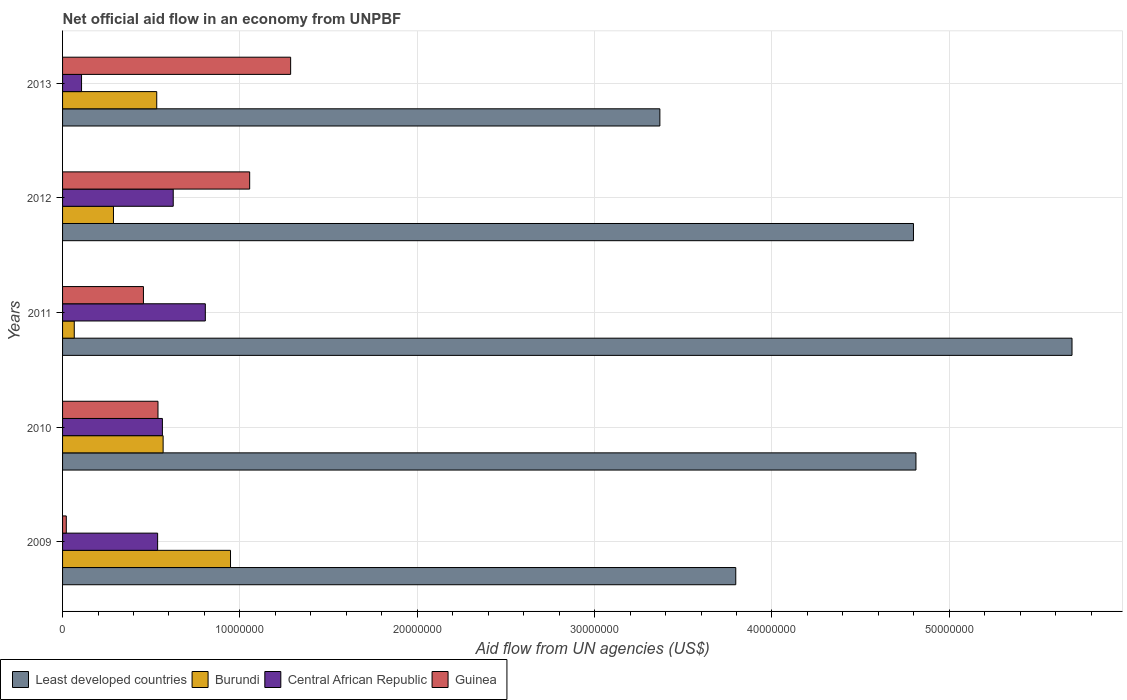How many groups of bars are there?
Keep it short and to the point. 5. Are the number of bars per tick equal to the number of legend labels?
Your response must be concise. Yes. Are the number of bars on each tick of the Y-axis equal?
Your response must be concise. Yes. How many bars are there on the 2nd tick from the top?
Ensure brevity in your answer.  4. How many bars are there on the 5th tick from the bottom?
Ensure brevity in your answer.  4. What is the label of the 4th group of bars from the top?
Give a very brief answer. 2010. In how many cases, is the number of bars for a given year not equal to the number of legend labels?
Ensure brevity in your answer.  0. What is the net official aid flow in Burundi in 2010?
Provide a succinct answer. 5.67e+06. Across all years, what is the maximum net official aid flow in Least developed countries?
Keep it short and to the point. 5.69e+07. Across all years, what is the minimum net official aid flow in Central African Republic?
Provide a succinct answer. 1.07e+06. In which year was the net official aid flow in Guinea minimum?
Offer a terse response. 2009. What is the total net official aid flow in Burundi in the graph?
Your answer should be very brief. 2.40e+07. What is the difference between the net official aid flow in Central African Republic in 2009 and that in 2013?
Provide a succinct answer. 4.29e+06. What is the difference between the net official aid flow in Guinea in 2009 and the net official aid flow in Burundi in 2013?
Provide a succinct answer. -5.10e+06. What is the average net official aid flow in Guinea per year?
Make the answer very short. 6.71e+06. In the year 2013, what is the difference between the net official aid flow in Least developed countries and net official aid flow in Guinea?
Your answer should be compact. 2.08e+07. In how many years, is the net official aid flow in Least developed countries greater than 36000000 US$?
Keep it short and to the point. 4. What is the ratio of the net official aid flow in Guinea in 2009 to that in 2013?
Offer a very short reply. 0.02. What is the difference between the highest and the second highest net official aid flow in Least developed countries?
Provide a short and direct response. 8.80e+06. What is the difference between the highest and the lowest net official aid flow in Burundi?
Offer a very short reply. 8.81e+06. Is the sum of the net official aid flow in Central African Republic in 2010 and 2012 greater than the maximum net official aid flow in Least developed countries across all years?
Your answer should be compact. No. What does the 3rd bar from the top in 2011 represents?
Ensure brevity in your answer.  Burundi. What does the 4th bar from the bottom in 2010 represents?
Keep it short and to the point. Guinea. Is it the case that in every year, the sum of the net official aid flow in Least developed countries and net official aid flow in Burundi is greater than the net official aid flow in Guinea?
Make the answer very short. Yes. How many bars are there?
Your answer should be compact. 20. How many years are there in the graph?
Make the answer very short. 5. What is the difference between two consecutive major ticks on the X-axis?
Provide a succinct answer. 1.00e+07. Are the values on the major ticks of X-axis written in scientific E-notation?
Your response must be concise. No. Does the graph contain grids?
Keep it short and to the point. Yes. Where does the legend appear in the graph?
Ensure brevity in your answer.  Bottom left. What is the title of the graph?
Provide a short and direct response. Net official aid flow in an economy from UNPBF. What is the label or title of the X-axis?
Your answer should be very brief. Aid flow from UN agencies (US$). What is the label or title of the Y-axis?
Your response must be concise. Years. What is the Aid flow from UN agencies (US$) in Least developed countries in 2009?
Ensure brevity in your answer.  3.80e+07. What is the Aid flow from UN agencies (US$) of Burundi in 2009?
Provide a short and direct response. 9.47e+06. What is the Aid flow from UN agencies (US$) of Central African Republic in 2009?
Offer a terse response. 5.36e+06. What is the Aid flow from UN agencies (US$) in Guinea in 2009?
Make the answer very short. 2.10e+05. What is the Aid flow from UN agencies (US$) of Least developed countries in 2010?
Provide a succinct answer. 4.81e+07. What is the Aid flow from UN agencies (US$) in Burundi in 2010?
Give a very brief answer. 5.67e+06. What is the Aid flow from UN agencies (US$) in Central African Republic in 2010?
Your answer should be very brief. 5.63e+06. What is the Aid flow from UN agencies (US$) in Guinea in 2010?
Provide a succinct answer. 5.38e+06. What is the Aid flow from UN agencies (US$) in Least developed countries in 2011?
Provide a succinct answer. 5.69e+07. What is the Aid flow from UN agencies (US$) in Central African Republic in 2011?
Your response must be concise. 8.05e+06. What is the Aid flow from UN agencies (US$) of Guinea in 2011?
Offer a terse response. 4.56e+06. What is the Aid flow from UN agencies (US$) in Least developed countries in 2012?
Offer a very short reply. 4.80e+07. What is the Aid flow from UN agencies (US$) in Burundi in 2012?
Make the answer very short. 2.87e+06. What is the Aid flow from UN agencies (US$) in Central African Republic in 2012?
Ensure brevity in your answer.  6.24e+06. What is the Aid flow from UN agencies (US$) of Guinea in 2012?
Offer a very short reply. 1.06e+07. What is the Aid flow from UN agencies (US$) of Least developed countries in 2013?
Ensure brevity in your answer.  3.37e+07. What is the Aid flow from UN agencies (US$) in Burundi in 2013?
Keep it short and to the point. 5.31e+06. What is the Aid flow from UN agencies (US$) of Central African Republic in 2013?
Give a very brief answer. 1.07e+06. What is the Aid flow from UN agencies (US$) of Guinea in 2013?
Offer a terse response. 1.29e+07. Across all years, what is the maximum Aid flow from UN agencies (US$) in Least developed countries?
Offer a very short reply. 5.69e+07. Across all years, what is the maximum Aid flow from UN agencies (US$) in Burundi?
Your answer should be very brief. 9.47e+06. Across all years, what is the maximum Aid flow from UN agencies (US$) of Central African Republic?
Offer a terse response. 8.05e+06. Across all years, what is the maximum Aid flow from UN agencies (US$) in Guinea?
Your answer should be very brief. 1.29e+07. Across all years, what is the minimum Aid flow from UN agencies (US$) of Least developed countries?
Give a very brief answer. 3.37e+07. Across all years, what is the minimum Aid flow from UN agencies (US$) in Burundi?
Offer a very short reply. 6.60e+05. Across all years, what is the minimum Aid flow from UN agencies (US$) of Central African Republic?
Give a very brief answer. 1.07e+06. What is the total Aid flow from UN agencies (US$) of Least developed countries in the graph?
Keep it short and to the point. 2.25e+08. What is the total Aid flow from UN agencies (US$) in Burundi in the graph?
Provide a succinct answer. 2.40e+07. What is the total Aid flow from UN agencies (US$) of Central African Republic in the graph?
Your answer should be very brief. 2.64e+07. What is the total Aid flow from UN agencies (US$) in Guinea in the graph?
Offer a terse response. 3.36e+07. What is the difference between the Aid flow from UN agencies (US$) in Least developed countries in 2009 and that in 2010?
Your answer should be compact. -1.02e+07. What is the difference between the Aid flow from UN agencies (US$) in Burundi in 2009 and that in 2010?
Offer a terse response. 3.80e+06. What is the difference between the Aid flow from UN agencies (US$) in Central African Republic in 2009 and that in 2010?
Provide a short and direct response. -2.70e+05. What is the difference between the Aid flow from UN agencies (US$) in Guinea in 2009 and that in 2010?
Offer a very short reply. -5.17e+06. What is the difference between the Aid flow from UN agencies (US$) of Least developed countries in 2009 and that in 2011?
Your answer should be compact. -1.90e+07. What is the difference between the Aid flow from UN agencies (US$) of Burundi in 2009 and that in 2011?
Give a very brief answer. 8.81e+06. What is the difference between the Aid flow from UN agencies (US$) in Central African Republic in 2009 and that in 2011?
Your answer should be very brief. -2.69e+06. What is the difference between the Aid flow from UN agencies (US$) of Guinea in 2009 and that in 2011?
Keep it short and to the point. -4.35e+06. What is the difference between the Aid flow from UN agencies (US$) in Least developed countries in 2009 and that in 2012?
Your response must be concise. -1.00e+07. What is the difference between the Aid flow from UN agencies (US$) of Burundi in 2009 and that in 2012?
Keep it short and to the point. 6.60e+06. What is the difference between the Aid flow from UN agencies (US$) in Central African Republic in 2009 and that in 2012?
Your answer should be compact. -8.80e+05. What is the difference between the Aid flow from UN agencies (US$) of Guinea in 2009 and that in 2012?
Give a very brief answer. -1.03e+07. What is the difference between the Aid flow from UN agencies (US$) in Least developed countries in 2009 and that in 2013?
Your answer should be compact. 4.28e+06. What is the difference between the Aid flow from UN agencies (US$) of Burundi in 2009 and that in 2013?
Your response must be concise. 4.16e+06. What is the difference between the Aid flow from UN agencies (US$) of Central African Republic in 2009 and that in 2013?
Offer a very short reply. 4.29e+06. What is the difference between the Aid flow from UN agencies (US$) of Guinea in 2009 and that in 2013?
Offer a terse response. -1.26e+07. What is the difference between the Aid flow from UN agencies (US$) in Least developed countries in 2010 and that in 2011?
Make the answer very short. -8.80e+06. What is the difference between the Aid flow from UN agencies (US$) in Burundi in 2010 and that in 2011?
Your response must be concise. 5.01e+06. What is the difference between the Aid flow from UN agencies (US$) of Central African Republic in 2010 and that in 2011?
Offer a terse response. -2.42e+06. What is the difference between the Aid flow from UN agencies (US$) of Guinea in 2010 and that in 2011?
Offer a very short reply. 8.20e+05. What is the difference between the Aid flow from UN agencies (US$) in Burundi in 2010 and that in 2012?
Your answer should be compact. 2.80e+06. What is the difference between the Aid flow from UN agencies (US$) of Central African Republic in 2010 and that in 2012?
Your response must be concise. -6.10e+05. What is the difference between the Aid flow from UN agencies (US$) of Guinea in 2010 and that in 2012?
Offer a very short reply. -5.17e+06. What is the difference between the Aid flow from UN agencies (US$) of Least developed countries in 2010 and that in 2013?
Make the answer very short. 1.44e+07. What is the difference between the Aid flow from UN agencies (US$) of Burundi in 2010 and that in 2013?
Provide a short and direct response. 3.60e+05. What is the difference between the Aid flow from UN agencies (US$) in Central African Republic in 2010 and that in 2013?
Offer a very short reply. 4.56e+06. What is the difference between the Aid flow from UN agencies (US$) in Guinea in 2010 and that in 2013?
Give a very brief answer. -7.48e+06. What is the difference between the Aid flow from UN agencies (US$) of Least developed countries in 2011 and that in 2012?
Make the answer very short. 8.94e+06. What is the difference between the Aid flow from UN agencies (US$) of Burundi in 2011 and that in 2012?
Your answer should be very brief. -2.21e+06. What is the difference between the Aid flow from UN agencies (US$) in Central African Republic in 2011 and that in 2012?
Offer a terse response. 1.81e+06. What is the difference between the Aid flow from UN agencies (US$) in Guinea in 2011 and that in 2012?
Give a very brief answer. -5.99e+06. What is the difference between the Aid flow from UN agencies (US$) in Least developed countries in 2011 and that in 2013?
Offer a terse response. 2.32e+07. What is the difference between the Aid flow from UN agencies (US$) of Burundi in 2011 and that in 2013?
Offer a terse response. -4.65e+06. What is the difference between the Aid flow from UN agencies (US$) of Central African Republic in 2011 and that in 2013?
Provide a succinct answer. 6.98e+06. What is the difference between the Aid flow from UN agencies (US$) of Guinea in 2011 and that in 2013?
Offer a terse response. -8.30e+06. What is the difference between the Aid flow from UN agencies (US$) of Least developed countries in 2012 and that in 2013?
Make the answer very short. 1.43e+07. What is the difference between the Aid flow from UN agencies (US$) in Burundi in 2012 and that in 2013?
Your answer should be compact. -2.44e+06. What is the difference between the Aid flow from UN agencies (US$) of Central African Republic in 2012 and that in 2013?
Keep it short and to the point. 5.17e+06. What is the difference between the Aid flow from UN agencies (US$) of Guinea in 2012 and that in 2013?
Make the answer very short. -2.31e+06. What is the difference between the Aid flow from UN agencies (US$) of Least developed countries in 2009 and the Aid flow from UN agencies (US$) of Burundi in 2010?
Offer a very short reply. 3.23e+07. What is the difference between the Aid flow from UN agencies (US$) in Least developed countries in 2009 and the Aid flow from UN agencies (US$) in Central African Republic in 2010?
Your answer should be compact. 3.23e+07. What is the difference between the Aid flow from UN agencies (US$) in Least developed countries in 2009 and the Aid flow from UN agencies (US$) in Guinea in 2010?
Give a very brief answer. 3.26e+07. What is the difference between the Aid flow from UN agencies (US$) in Burundi in 2009 and the Aid flow from UN agencies (US$) in Central African Republic in 2010?
Ensure brevity in your answer.  3.84e+06. What is the difference between the Aid flow from UN agencies (US$) in Burundi in 2009 and the Aid flow from UN agencies (US$) in Guinea in 2010?
Ensure brevity in your answer.  4.09e+06. What is the difference between the Aid flow from UN agencies (US$) of Central African Republic in 2009 and the Aid flow from UN agencies (US$) of Guinea in 2010?
Provide a short and direct response. -2.00e+04. What is the difference between the Aid flow from UN agencies (US$) in Least developed countries in 2009 and the Aid flow from UN agencies (US$) in Burundi in 2011?
Give a very brief answer. 3.73e+07. What is the difference between the Aid flow from UN agencies (US$) of Least developed countries in 2009 and the Aid flow from UN agencies (US$) of Central African Republic in 2011?
Your answer should be very brief. 2.99e+07. What is the difference between the Aid flow from UN agencies (US$) in Least developed countries in 2009 and the Aid flow from UN agencies (US$) in Guinea in 2011?
Keep it short and to the point. 3.34e+07. What is the difference between the Aid flow from UN agencies (US$) in Burundi in 2009 and the Aid flow from UN agencies (US$) in Central African Republic in 2011?
Give a very brief answer. 1.42e+06. What is the difference between the Aid flow from UN agencies (US$) in Burundi in 2009 and the Aid flow from UN agencies (US$) in Guinea in 2011?
Offer a very short reply. 4.91e+06. What is the difference between the Aid flow from UN agencies (US$) in Central African Republic in 2009 and the Aid flow from UN agencies (US$) in Guinea in 2011?
Your answer should be compact. 8.00e+05. What is the difference between the Aid flow from UN agencies (US$) in Least developed countries in 2009 and the Aid flow from UN agencies (US$) in Burundi in 2012?
Your answer should be compact. 3.51e+07. What is the difference between the Aid flow from UN agencies (US$) of Least developed countries in 2009 and the Aid flow from UN agencies (US$) of Central African Republic in 2012?
Give a very brief answer. 3.17e+07. What is the difference between the Aid flow from UN agencies (US$) in Least developed countries in 2009 and the Aid flow from UN agencies (US$) in Guinea in 2012?
Offer a very short reply. 2.74e+07. What is the difference between the Aid flow from UN agencies (US$) in Burundi in 2009 and the Aid flow from UN agencies (US$) in Central African Republic in 2012?
Your answer should be very brief. 3.23e+06. What is the difference between the Aid flow from UN agencies (US$) of Burundi in 2009 and the Aid flow from UN agencies (US$) of Guinea in 2012?
Ensure brevity in your answer.  -1.08e+06. What is the difference between the Aid flow from UN agencies (US$) in Central African Republic in 2009 and the Aid flow from UN agencies (US$) in Guinea in 2012?
Keep it short and to the point. -5.19e+06. What is the difference between the Aid flow from UN agencies (US$) in Least developed countries in 2009 and the Aid flow from UN agencies (US$) in Burundi in 2013?
Make the answer very short. 3.26e+07. What is the difference between the Aid flow from UN agencies (US$) in Least developed countries in 2009 and the Aid flow from UN agencies (US$) in Central African Republic in 2013?
Provide a succinct answer. 3.69e+07. What is the difference between the Aid flow from UN agencies (US$) in Least developed countries in 2009 and the Aid flow from UN agencies (US$) in Guinea in 2013?
Offer a very short reply. 2.51e+07. What is the difference between the Aid flow from UN agencies (US$) in Burundi in 2009 and the Aid flow from UN agencies (US$) in Central African Republic in 2013?
Provide a succinct answer. 8.40e+06. What is the difference between the Aid flow from UN agencies (US$) in Burundi in 2009 and the Aid flow from UN agencies (US$) in Guinea in 2013?
Offer a terse response. -3.39e+06. What is the difference between the Aid flow from UN agencies (US$) of Central African Republic in 2009 and the Aid flow from UN agencies (US$) of Guinea in 2013?
Offer a terse response. -7.50e+06. What is the difference between the Aid flow from UN agencies (US$) of Least developed countries in 2010 and the Aid flow from UN agencies (US$) of Burundi in 2011?
Offer a terse response. 4.75e+07. What is the difference between the Aid flow from UN agencies (US$) in Least developed countries in 2010 and the Aid flow from UN agencies (US$) in Central African Republic in 2011?
Provide a short and direct response. 4.01e+07. What is the difference between the Aid flow from UN agencies (US$) of Least developed countries in 2010 and the Aid flow from UN agencies (US$) of Guinea in 2011?
Offer a terse response. 4.36e+07. What is the difference between the Aid flow from UN agencies (US$) of Burundi in 2010 and the Aid flow from UN agencies (US$) of Central African Republic in 2011?
Provide a short and direct response. -2.38e+06. What is the difference between the Aid flow from UN agencies (US$) of Burundi in 2010 and the Aid flow from UN agencies (US$) of Guinea in 2011?
Your response must be concise. 1.11e+06. What is the difference between the Aid flow from UN agencies (US$) in Central African Republic in 2010 and the Aid flow from UN agencies (US$) in Guinea in 2011?
Provide a succinct answer. 1.07e+06. What is the difference between the Aid flow from UN agencies (US$) in Least developed countries in 2010 and the Aid flow from UN agencies (US$) in Burundi in 2012?
Your answer should be compact. 4.52e+07. What is the difference between the Aid flow from UN agencies (US$) of Least developed countries in 2010 and the Aid flow from UN agencies (US$) of Central African Republic in 2012?
Provide a short and direct response. 4.19e+07. What is the difference between the Aid flow from UN agencies (US$) of Least developed countries in 2010 and the Aid flow from UN agencies (US$) of Guinea in 2012?
Keep it short and to the point. 3.76e+07. What is the difference between the Aid flow from UN agencies (US$) of Burundi in 2010 and the Aid flow from UN agencies (US$) of Central African Republic in 2012?
Keep it short and to the point. -5.70e+05. What is the difference between the Aid flow from UN agencies (US$) of Burundi in 2010 and the Aid flow from UN agencies (US$) of Guinea in 2012?
Your answer should be compact. -4.88e+06. What is the difference between the Aid flow from UN agencies (US$) of Central African Republic in 2010 and the Aid flow from UN agencies (US$) of Guinea in 2012?
Offer a very short reply. -4.92e+06. What is the difference between the Aid flow from UN agencies (US$) of Least developed countries in 2010 and the Aid flow from UN agencies (US$) of Burundi in 2013?
Provide a succinct answer. 4.28e+07. What is the difference between the Aid flow from UN agencies (US$) in Least developed countries in 2010 and the Aid flow from UN agencies (US$) in Central African Republic in 2013?
Offer a very short reply. 4.70e+07. What is the difference between the Aid flow from UN agencies (US$) in Least developed countries in 2010 and the Aid flow from UN agencies (US$) in Guinea in 2013?
Offer a terse response. 3.53e+07. What is the difference between the Aid flow from UN agencies (US$) in Burundi in 2010 and the Aid flow from UN agencies (US$) in Central African Republic in 2013?
Provide a succinct answer. 4.60e+06. What is the difference between the Aid flow from UN agencies (US$) in Burundi in 2010 and the Aid flow from UN agencies (US$) in Guinea in 2013?
Provide a short and direct response. -7.19e+06. What is the difference between the Aid flow from UN agencies (US$) of Central African Republic in 2010 and the Aid flow from UN agencies (US$) of Guinea in 2013?
Ensure brevity in your answer.  -7.23e+06. What is the difference between the Aid flow from UN agencies (US$) in Least developed countries in 2011 and the Aid flow from UN agencies (US$) in Burundi in 2012?
Your response must be concise. 5.40e+07. What is the difference between the Aid flow from UN agencies (US$) of Least developed countries in 2011 and the Aid flow from UN agencies (US$) of Central African Republic in 2012?
Make the answer very short. 5.07e+07. What is the difference between the Aid flow from UN agencies (US$) of Least developed countries in 2011 and the Aid flow from UN agencies (US$) of Guinea in 2012?
Give a very brief answer. 4.64e+07. What is the difference between the Aid flow from UN agencies (US$) in Burundi in 2011 and the Aid flow from UN agencies (US$) in Central African Republic in 2012?
Provide a short and direct response. -5.58e+06. What is the difference between the Aid flow from UN agencies (US$) in Burundi in 2011 and the Aid flow from UN agencies (US$) in Guinea in 2012?
Your answer should be compact. -9.89e+06. What is the difference between the Aid flow from UN agencies (US$) in Central African Republic in 2011 and the Aid flow from UN agencies (US$) in Guinea in 2012?
Give a very brief answer. -2.50e+06. What is the difference between the Aid flow from UN agencies (US$) in Least developed countries in 2011 and the Aid flow from UN agencies (US$) in Burundi in 2013?
Ensure brevity in your answer.  5.16e+07. What is the difference between the Aid flow from UN agencies (US$) of Least developed countries in 2011 and the Aid flow from UN agencies (US$) of Central African Republic in 2013?
Your answer should be very brief. 5.58e+07. What is the difference between the Aid flow from UN agencies (US$) of Least developed countries in 2011 and the Aid flow from UN agencies (US$) of Guinea in 2013?
Your answer should be very brief. 4.41e+07. What is the difference between the Aid flow from UN agencies (US$) in Burundi in 2011 and the Aid flow from UN agencies (US$) in Central African Republic in 2013?
Your response must be concise. -4.10e+05. What is the difference between the Aid flow from UN agencies (US$) in Burundi in 2011 and the Aid flow from UN agencies (US$) in Guinea in 2013?
Your answer should be very brief. -1.22e+07. What is the difference between the Aid flow from UN agencies (US$) of Central African Republic in 2011 and the Aid flow from UN agencies (US$) of Guinea in 2013?
Offer a very short reply. -4.81e+06. What is the difference between the Aid flow from UN agencies (US$) of Least developed countries in 2012 and the Aid flow from UN agencies (US$) of Burundi in 2013?
Your response must be concise. 4.27e+07. What is the difference between the Aid flow from UN agencies (US$) in Least developed countries in 2012 and the Aid flow from UN agencies (US$) in Central African Republic in 2013?
Keep it short and to the point. 4.69e+07. What is the difference between the Aid flow from UN agencies (US$) in Least developed countries in 2012 and the Aid flow from UN agencies (US$) in Guinea in 2013?
Your response must be concise. 3.51e+07. What is the difference between the Aid flow from UN agencies (US$) of Burundi in 2012 and the Aid flow from UN agencies (US$) of Central African Republic in 2013?
Make the answer very short. 1.80e+06. What is the difference between the Aid flow from UN agencies (US$) of Burundi in 2012 and the Aid flow from UN agencies (US$) of Guinea in 2013?
Provide a short and direct response. -9.99e+06. What is the difference between the Aid flow from UN agencies (US$) of Central African Republic in 2012 and the Aid flow from UN agencies (US$) of Guinea in 2013?
Your response must be concise. -6.62e+06. What is the average Aid flow from UN agencies (US$) of Least developed countries per year?
Your answer should be compact. 4.49e+07. What is the average Aid flow from UN agencies (US$) in Burundi per year?
Keep it short and to the point. 4.80e+06. What is the average Aid flow from UN agencies (US$) of Central African Republic per year?
Make the answer very short. 5.27e+06. What is the average Aid flow from UN agencies (US$) of Guinea per year?
Your response must be concise. 6.71e+06. In the year 2009, what is the difference between the Aid flow from UN agencies (US$) of Least developed countries and Aid flow from UN agencies (US$) of Burundi?
Make the answer very short. 2.85e+07. In the year 2009, what is the difference between the Aid flow from UN agencies (US$) in Least developed countries and Aid flow from UN agencies (US$) in Central African Republic?
Provide a short and direct response. 3.26e+07. In the year 2009, what is the difference between the Aid flow from UN agencies (US$) of Least developed countries and Aid flow from UN agencies (US$) of Guinea?
Keep it short and to the point. 3.78e+07. In the year 2009, what is the difference between the Aid flow from UN agencies (US$) of Burundi and Aid flow from UN agencies (US$) of Central African Republic?
Provide a succinct answer. 4.11e+06. In the year 2009, what is the difference between the Aid flow from UN agencies (US$) in Burundi and Aid flow from UN agencies (US$) in Guinea?
Your answer should be very brief. 9.26e+06. In the year 2009, what is the difference between the Aid flow from UN agencies (US$) in Central African Republic and Aid flow from UN agencies (US$) in Guinea?
Your answer should be compact. 5.15e+06. In the year 2010, what is the difference between the Aid flow from UN agencies (US$) in Least developed countries and Aid flow from UN agencies (US$) in Burundi?
Your answer should be compact. 4.24e+07. In the year 2010, what is the difference between the Aid flow from UN agencies (US$) of Least developed countries and Aid flow from UN agencies (US$) of Central African Republic?
Make the answer very short. 4.25e+07. In the year 2010, what is the difference between the Aid flow from UN agencies (US$) in Least developed countries and Aid flow from UN agencies (US$) in Guinea?
Offer a very short reply. 4.27e+07. In the year 2010, what is the difference between the Aid flow from UN agencies (US$) in Burundi and Aid flow from UN agencies (US$) in Central African Republic?
Your response must be concise. 4.00e+04. In the year 2011, what is the difference between the Aid flow from UN agencies (US$) of Least developed countries and Aid flow from UN agencies (US$) of Burundi?
Your answer should be compact. 5.63e+07. In the year 2011, what is the difference between the Aid flow from UN agencies (US$) of Least developed countries and Aid flow from UN agencies (US$) of Central African Republic?
Your answer should be compact. 4.89e+07. In the year 2011, what is the difference between the Aid flow from UN agencies (US$) in Least developed countries and Aid flow from UN agencies (US$) in Guinea?
Provide a short and direct response. 5.24e+07. In the year 2011, what is the difference between the Aid flow from UN agencies (US$) in Burundi and Aid flow from UN agencies (US$) in Central African Republic?
Provide a short and direct response. -7.39e+06. In the year 2011, what is the difference between the Aid flow from UN agencies (US$) in Burundi and Aid flow from UN agencies (US$) in Guinea?
Offer a terse response. -3.90e+06. In the year 2011, what is the difference between the Aid flow from UN agencies (US$) of Central African Republic and Aid flow from UN agencies (US$) of Guinea?
Ensure brevity in your answer.  3.49e+06. In the year 2012, what is the difference between the Aid flow from UN agencies (US$) in Least developed countries and Aid flow from UN agencies (US$) in Burundi?
Provide a short and direct response. 4.51e+07. In the year 2012, what is the difference between the Aid flow from UN agencies (US$) of Least developed countries and Aid flow from UN agencies (US$) of Central African Republic?
Offer a terse response. 4.17e+07. In the year 2012, what is the difference between the Aid flow from UN agencies (US$) in Least developed countries and Aid flow from UN agencies (US$) in Guinea?
Your answer should be very brief. 3.74e+07. In the year 2012, what is the difference between the Aid flow from UN agencies (US$) in Burundi and Aid flow from UN agencies (US$) in Central African Republic?
Your answer should be compact. -3.37e+06. In the year 2012, what is the difference between the Aid flow from UN agencies (US$) in Burundi and Aid flow from UN agencies (US$) in Guinea?
Ensure brevity in your answer.  -7.68e+06. In the year 2012, what is the difference between the Aid flow from UN agencies (US$) of Central African Republic and Aid flow from UN agencies (US$) of Guinea?
Your answer should be compact. -4.31e+06. In the year 2013, what is the difference between the Aid flow from UN agencies (US$) of Least developed countries and Aid flow from UN agencies (US$) of Burundi?
Provide a short and direct response. 2.84e+07. In the year 2013, what is the difference between the Aid flow from UN agencies (US$) of Least developed countries and Aid flow from UN agencies (US$) of Central African Republic?
Provide a succinct answer. 3.26e+07. In the year 2013, what is the difference between the Aid flow from UN agencies (US$) in Least developed countries and Aid flow from UN agencies (US$) in Guinea?
Ensure brevity in your answer.  2.08e+07. In the year 2013, what is the difference between the Aid flow from UN agencies (US$) in Burundi and Aid flow from UN agencies (US$) in Central African Republic?
Keep it short and to the point. 4.24e+06. In the year 2013, what is the difference between the Aid flow from UN agencies (US$) in Burundi and Aid flow from UN agencies (US$) in Guinea?
Your answer should be very brief. -7.55e+06. In the year 2013, what is the difference between the Aid flow from UN agencies (US$) in Central African Republic and Aid flow from UN agencies (US$) in Guinea?
Make the answer very short. -1.18e+07. What is the ratio of the Aid flow from UN agencies (US$) in Least developed countries in 2009 to that in 2010?
Your response must be concise. 0.79. What is the ratio of the Aid flow from UN agencies (US$) in Burundi in 2009 to that in 2010?
Offer a very short reply. 1.67. What is the ratio of the Aid flow from UN agencies (US$) of Central African Republic in 2009 to that in 2010?
Provide a short and direct response. 0.95. What is the ratio of the Aid flow from UN agencies (US$) in Guinea in 2009 to that in 2010?
Provide a short and direct response. 0.04. What is the ratio of the Aid flow from UN agencies (US$) of Least developed countries in 2009 to that in 2011?
Keep it short and to the point. 0.67. What is the ratio of the Aid flow from UN agencies (US$) in Burundi in 2009 to that in 2011?
Make the answer very short. 14.35. What is the ratio of the Aid flow from UN agencies (US$) in Central African Republic in 2009 to that in 2011?
Keep it short and to the point. 0.67. What is the ratio of the Aid flow from UN agencies (US$) in Guinea in 2009 to that in 2011?
Keep it short and to the point. 0.05. What is the ratio of the Aid flow from UN agencies (US$) of Least developed countries in 2009 to that in 2012?
Offer a very short reply. 0.79. What is the ratio of the Aid flow from UN agencies (US$) in Burundi in 2009 to that in 2012?
Provide a succinct answer. 3.3. What is the ratio of the Aid flow from UN agencies (US$) of Central African Republic in 2009 to that in 2012?
Provide a succinct answer. 0.86. What is the ratio of the Aid flow from UN agencies (US$) of Guinea in 2009 to that in 2012?
Provide a short and direct response. 0.02. What is the ratio of the Aid flow from UN agencies (US$) of Least developed countries in 2009 to that in 2013?
Your response must be concise. 1.13. What is the ratio of the Aid flow from UN agencies (US$) in Burundi in 2009 to that in 2013?
Provide a succinct answer. 1.78. What is the ratio of the Aid flow from UN agencies (US$) in Central African Republic in 2009 to that in 2013?
Provide a succinct answer. 5.01. What is the ratio of the Aid flow from UN agencies (US$) of Guinea in 2009 to that in 2013?
Provide a short and direct response. 0.02. What is the ratio of the Aid flow from UN agencies (US$) of Least developed countries in 2010 to that in 2011?
Give a very brief answer. 0.85. What is the ratio of the Aid flow from UN agencies (US$) of Burundi in 2010 to that in 2011?
Provide a short and direct response. 8.59. What is the ratio of the Aid flow from UN agencies (US$) of Central African Republic in 2010 to that in 2011?
Make the answer very short. 0.7. What is the ratio of the Aid flow from UN agencies (US$) in Guinea in 2010 to that in 2011?
Provide a short and direct response. 1.18. What is the ratio of the Aid flow from UN agencies (US$) in Burundi in 2010 to that in 2012?
Your answer should be compact. 1.98. What is the ratio of the Aid flow from UN agencies (US$) of Central African Republic in 2010 to that in 2012?
Your response must be concise. 0.9. What is the ratio of the Aid flow from UN agencies (US$) of Guinea in 2010 to that in 2012?
Your answer should be very brief. 0.51. What is the ratio of the Aid flow from UN agencies (US$) of Least developed countries in 2010 to that in 2013?
Provide a short and direct response. 1.43. What is the ratio of the Aid flow from UN agencies (US$) of Burundi in 2010 to that in 2013?
Provide a succinct answer. 1.07. What is the ratio of the Aid flow from UN agencies (US$) of Central African Republic in 2010 to that in 2013?
Make the answer very short. 5.26. What is the ratio of the Aid flow from UN agencies (US$) in Guinea in 2010 to that in 2013?
Provide a short and direct response. 0.42. What is the ratio of the Aid flow from UN agencies (US$) of Least developed countries in 2011 to that in 2012?
Your answer should be compact. 1.19. What is the ratio of the Aid flow from UN agencies (US$) in Burundi in 2011 to that in 2012?
Offer a terse response. 0.23. What is the ratio of the Aid flow from UN agencies (US$) of Central African Republic in 2011 to that in 2012?
Ensure brevity in your answer.  1.29. What is the ratio of the Aid flow from UN agencies (US$) of Guinea in 2011 to that in 2012?
Give a very brief answer. 0.43. What is the ratio of the Aid flow from UN agencies (US$) of Least developed countries in 2011 to that in 2013?
Give a very brief answer. 1.69. What is the ratio of the Aid flow from UN agencies (US$) in Burundi in 2011 to that in 2013?
Offer a very short reply. 0.12. What is the ratio of the Aid flow from UN agencies (US$) of Central African Republic in 2011 to that in 2013?
Offer a terse response. 7.52. What is the ratio of the Aid flow from UN agencies (US$) in Guinea in 2011 to that in 2013?
Your response must be concise. 0.35. What is the ratio of the Aid flow from UN agencies (US$) in Least developed countries in 2012 to that in 2013?
Your answer should be very brief. 1.42. What is the ratio of the Aid flow from UN agencies (US$) in Burundi in 2012 to that in 2013?
Offer a very short reply. 0.54. What is the ratio of the Aid flow from UN agencies (US$) of Central African Republic in 2012 to that in 2013?
Offer a terse response. 5.83. What is the ratio of the Aid flow from UN agencies (US$) of Guinea in 2012 to that in 2013?
Give a very brief answer. 0.82. What is the difference between the highest and the second highest Aid flow from UN agencies (US$) in Least developed countries?
Keep it short and to the point. 8.80e+06. What is the difference between the highest and the second highest Aid flow from UN agencies (US$) in Burundi?
Offer a terse response. 3.80e+06. What is the difference between the highest and the second highest Aid flow from UN agencies (US$) in Central African Republic?
Keep it short and to the point. 1.81e+06. What is the difference between the highest and the second highest Aid flow from UN agencies (US$) of Guinea?
Keep it short and to the point. 2.31e+06. What is the difference between the highest and the lowest Aid flow from UN agencies (US$) of Least developed countries?
Keep it short and to the point. 2.32e+07. What is the difference between the highest and the lowest Aid flow from UN agencies (US$) of Burundi?
Give a very brief answer. 8.81e+06. What is the difference between the highest and the lowest Aid flow from UN agencies (US$) of Central African Republic?
Provide a succinct answer. 6.98e+06. What is the difference between the highest and the lowest Aid flow from UN agencies (US$) in Guinea?
Provide a short and direct response. 1.26e+07. 